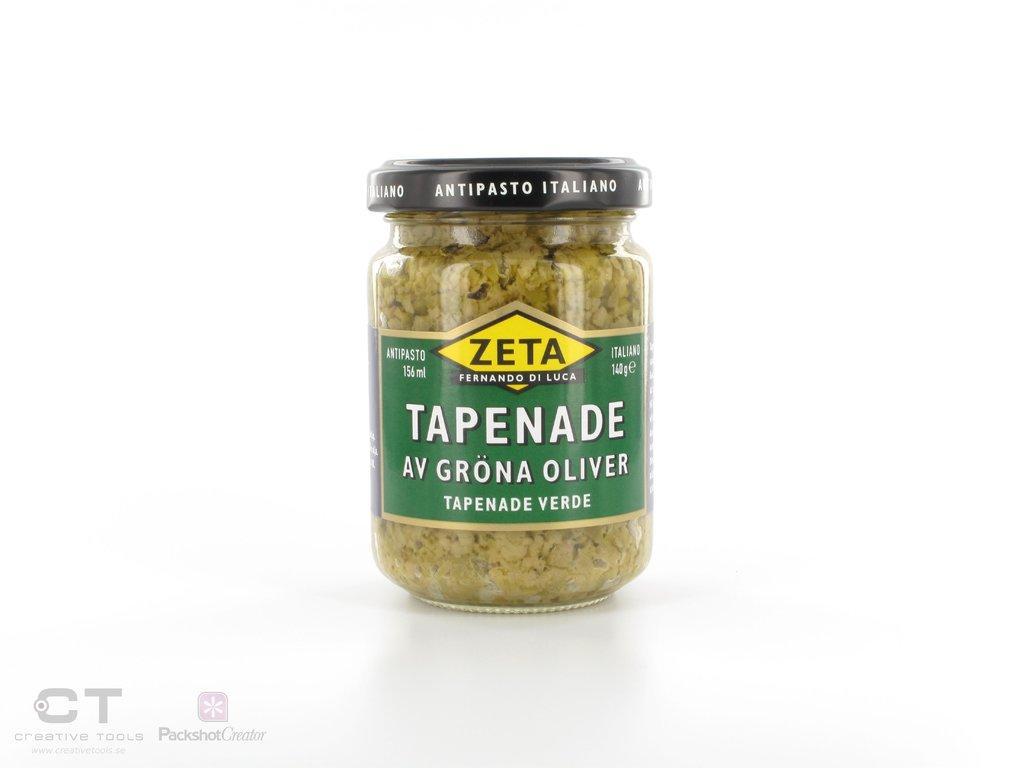Describe this image in one or two sentences. In this image there is a glass bottle, in that bottle there is food item. 